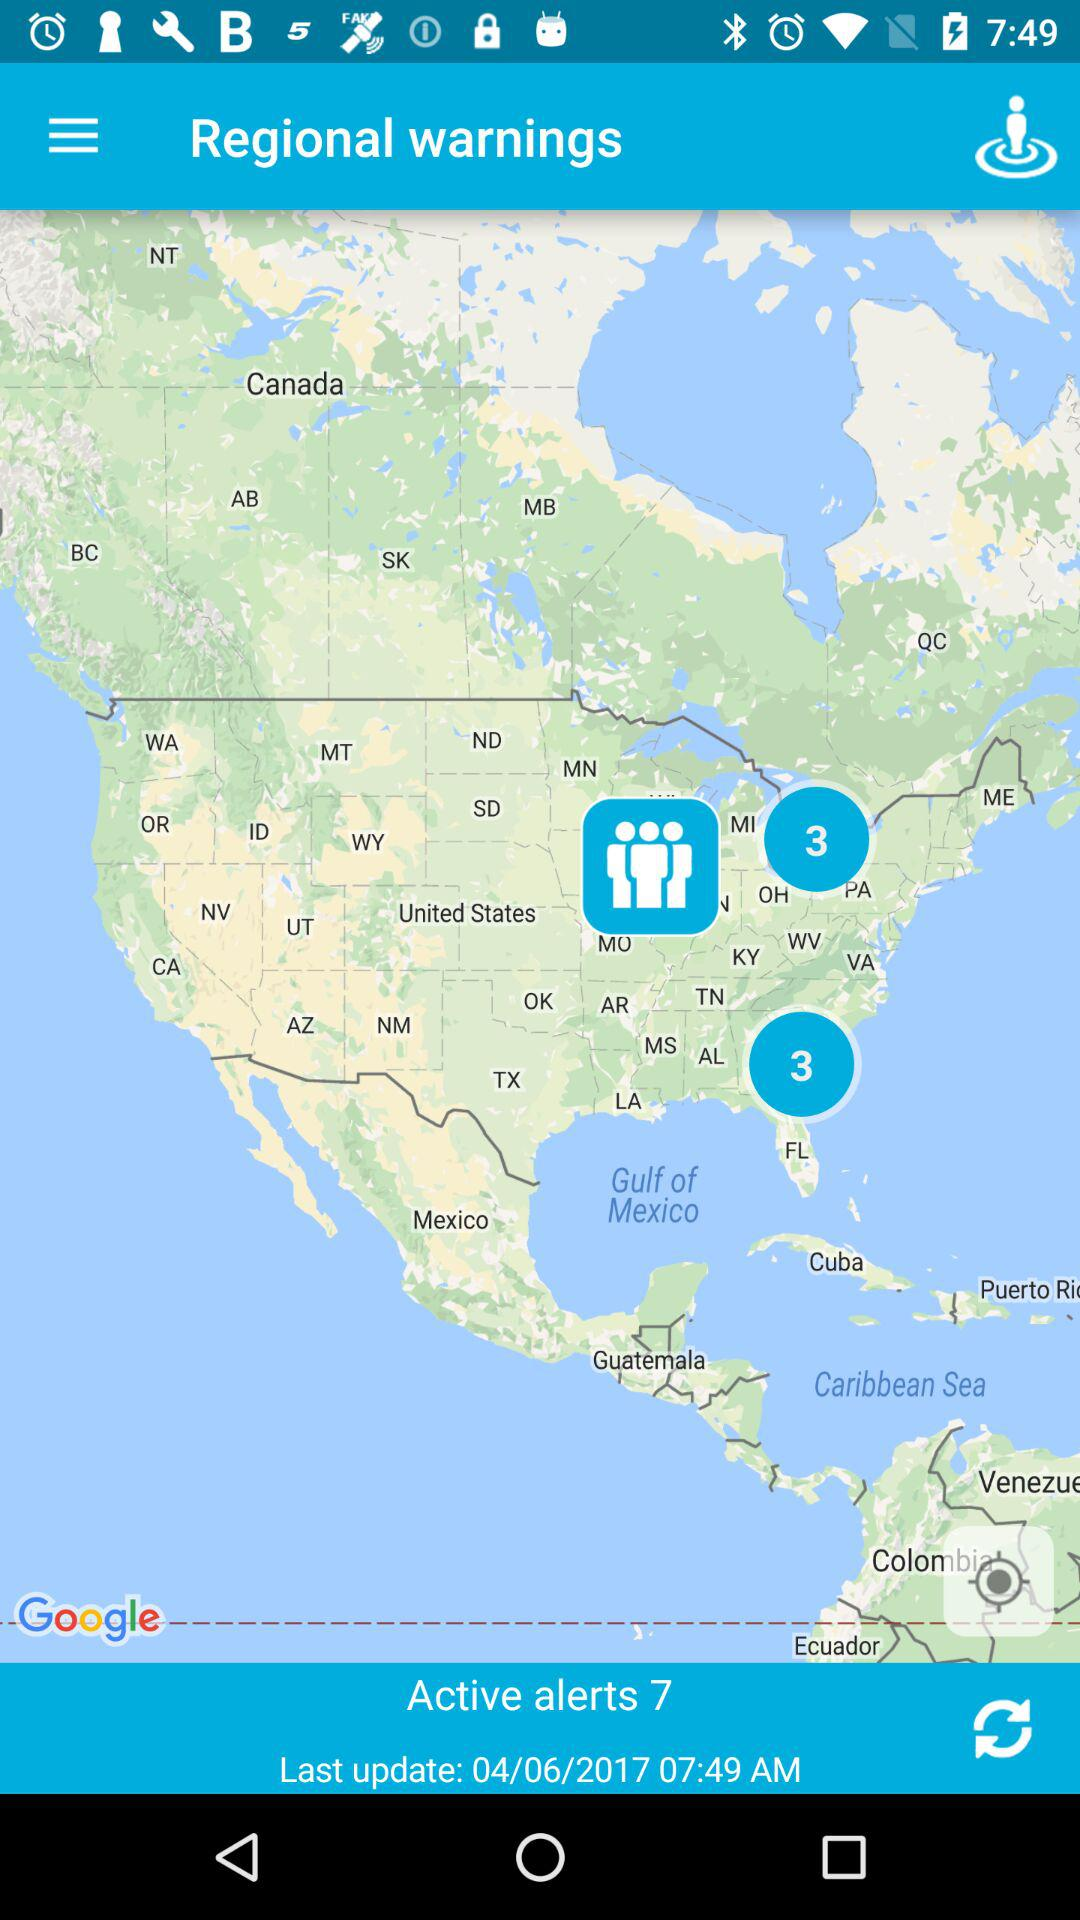How many active alerts are there? There are 7 active alerts. 